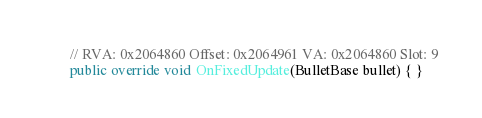Convert code to text. <code><loc_0><loc_0><loc_500><loc_500><_C#_>
	// RVA: 0x2064860 Offset: 0x2064961 VA: 0x2064860 Slot: 9
	public override void OnFixedUpdate(BulletBase bullet) { }
</code> 